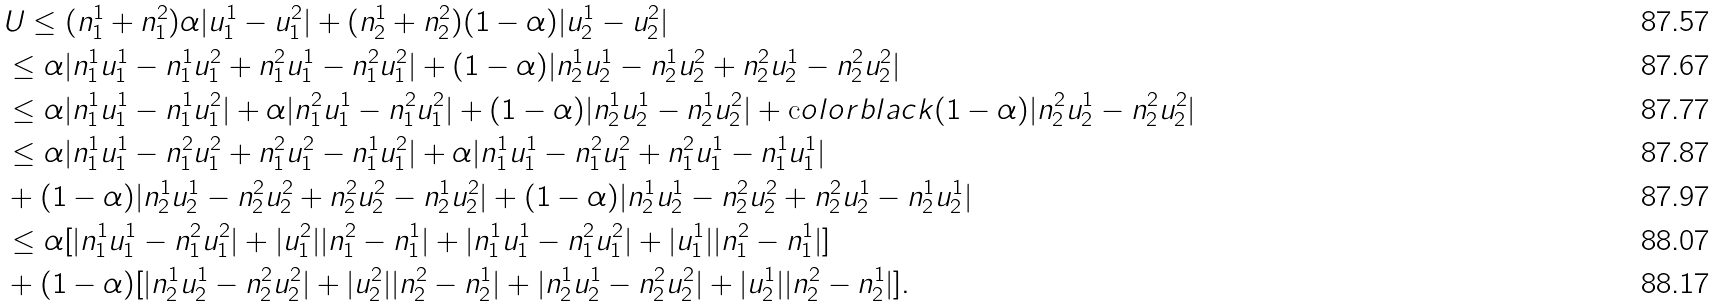Convert formula to latex. <formula><loc_0><loc_0><loc_500><loc_500>& U \leq ( n _ { 1 } ^ { 1 } + n _ { 1 } ^ { 2 } ) \alpha | u _ { 1 } ^ { 1 } - u _ { 1 } ^ { 2 } | + ( n _ { 2 } ^ { 1 } + n _ { 2 } ^ { 2 } ) ( 1 - \alpha ) | u _ { 2 } ^ { 1 } - u _ { 2 } ^ { 2 } | \\ & \leq \alpha | n _ { 1 } ^ { 1 } u _ { 1 } ^ { 1 } - n _ { 1 } ^ { 1 } u _ { 1 } ^ { 2 } + n _ { 1 } ^ { 2 } u _ { 1 } ^ { 1 } - n _ { 1 } ^ { 2 } u _ { 1 } ^ { 2 } | + ( 1 - \alpha ) | n _ { 2 } ^ { 1 } u _ { 2 } ^ { 1 } - n _ { 2 } ^ { 1 } u _ { 2 } ^ { 2 } + n _ { 2 } ^ { 2 } u _ { 2 } ^ { 1 } - n _ { 2 } ^ { 2 } u _ { 2 } ^ { 2 } | \\ & \leq \alpha | n _ { 1 } ^ { 1 } u _ { 1 } ^ { 1 } - n _ { 1 } ^ { 1 } u _ { 1 } ^ { 2 } | + \alpha | n _ { 1 } ^ { 2 } u _ { 1 } ^ { 1 } - n _ { 1 } ^ { 2 } u _ { 1 } ^ { 2 } | + ( 1 - \alpha ) | n _ { 2 } ^ { 1 } u _ { 2 } ^ { 1 } - n _ { 2 } ^ { 1 } u _ { 2 } ^ { 2 } | + \text  color{black} { ( 1 - \alpha ) } | n _ { 2 } ^ { 2 } u _ { 2 } ^ { 1 } - n _ { 2 } ^ { 2 } u _ { 2 } ^ { 2 } | \\ & \leq \alpha | n _ { 1 } ^ { 1 } u _ { 1 } ^ { 1 } - n _ { 1 } ^ { 2 } u _ { 1 } ^ { 2 } + n _ { 1 } ^ { 2 } u _ { 1 } ^ { 2 } - n _ { 1 } ^ { 1 } u _ { 1 } ^ { 2 } | + \alpha | n _ { 1 } ^ { 1 } u _ { 1 } ^ { 1 } - n _ { 1 } ^ { 2 } u _ { 1 } ^ { 2 } + n _ { 1 } ^ { 2 } u _ { 1 } ^ { 1 } - n _ { 1 } ^ { 1 } u _ { 1 } ^ { 1 } | \\ & + ( 1 - \alpha ) | n _ { 2 } ^ { 1 } u _ { 2 } ^ { 1 } - n _ { 2 } ^ { 2 } u _ { 2 } ^ { 2 } + n _ { 2 } ^ { 2 } u _ { 2 } ^ { 2 } - n _ { 2 } ^ { 1 } u _ { 2 } ^ { 2 } | + ( 1 - \alpha ) | n _ { 2 } ^ { 1 } u _ { 2 } ^ { 1 } - n _ { 2 } ^ { 2 } u _ { 2 } ^ { 2 } + n _ { 2 } ^ { 2 } u _ { 2 } ^ { 1 } - n _ { 2 } ^ { 1 } u _ { 2 } ^ { 1 } | \\ & \leq \alpha [ | n _ { 1 } ^ { 1 } u _ { 1 } ^ { 1 } - n _ { 1 } ^ { 2 } u _ { 1 } ^ { 2 } | + | u _ { 1 } ^ { 2 } | | n _ { 1 } ^ { 2 } - n _ { 1 } ^ { 1 } | + | n _ { 1 } ^ { 1 } u _ { 1 } ^ { 1 } - n _ { 1 } ^ { 2 } u _ { 1 } ^ { 2 } | + | u _ { 1 } ^ { 1 } | | n _ { 1 } ^ { 2 } - n _ { 1 } ^ { 1 } | ] \\ & + ( 1 - \alpha ) [ | n _ { 2 } ^ { 1 } u _ { 2 } ^ { 1 } - n _ { 2 } ^ { 2 } u _ { 2 } ^ { 2 } | + | u _ { 2 } ^ { 2 } | | n _ { 2 } ^ { 2 } - n _ { 2 } ^ { 1 } | + | n _ { 2 } ^ { 1 } u _ { 2 } ^ { 1 } - n _ { 2 } ^ { 2 } u _ { 2 } ^ { 2 } | + | u _ { 2 } ^ { 1 } | | n _ { 2 } ^ { 2 } - n _ { 2 } ^ { 1 } | ] .</formula> 